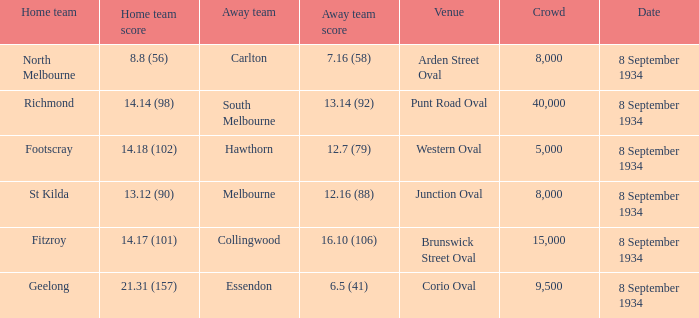When the Home team scored 14.14 (98), what did the Away Team score? 13.14 (92). 